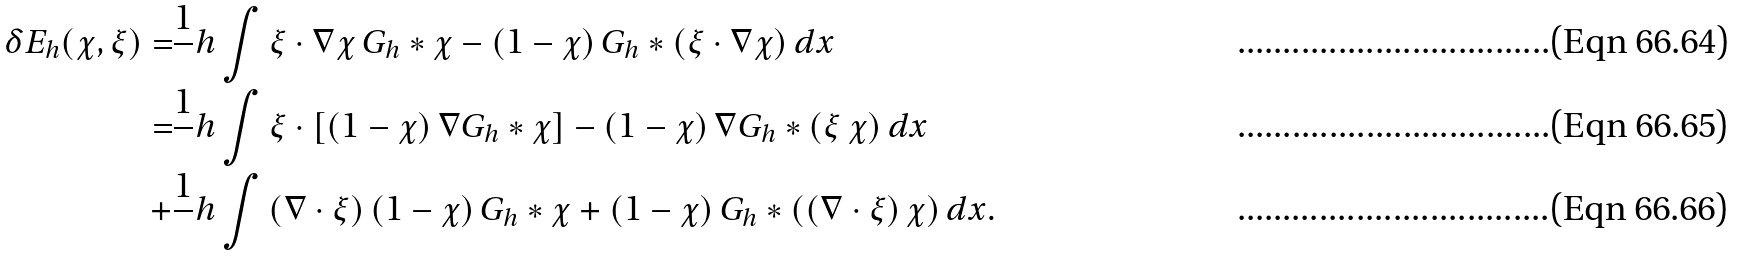<formula> <loc_0><loc_0><loc_500><loc_500>\delta E _ { h } ( \chi , \xi ) = & \frac { 1 } { \ } h \int \xi \cdot \nabla \chi \, G _ { h } \ast \chi - \left ( 1 - \chi \right ) G _ { h } \ast \left ( \xi \cdot \nabla \chi \right ) d x \\ = & \frac { 1 } { \ } h \int \xi \cdot \left [ \left ( 1 - \chi \right ) \nabla G _ { h } \ast \chi \right ] - \left ( 1 - \chi \right ) \nabla G _ { h } \ast \left ( \xi \, \chi \right ) d x \\ + & \frac { 1 } { \ } h \int \left ( \nabla \cdot \xi \right ) \left ( 1 - \chi \right ) G _ { h } \ast \chi + \left ( 1 - \chi \right ) G _ { h } \ast \left ( \left ( \nabla \cdot \xi \right ) \chi \right ) d x .</formula> 